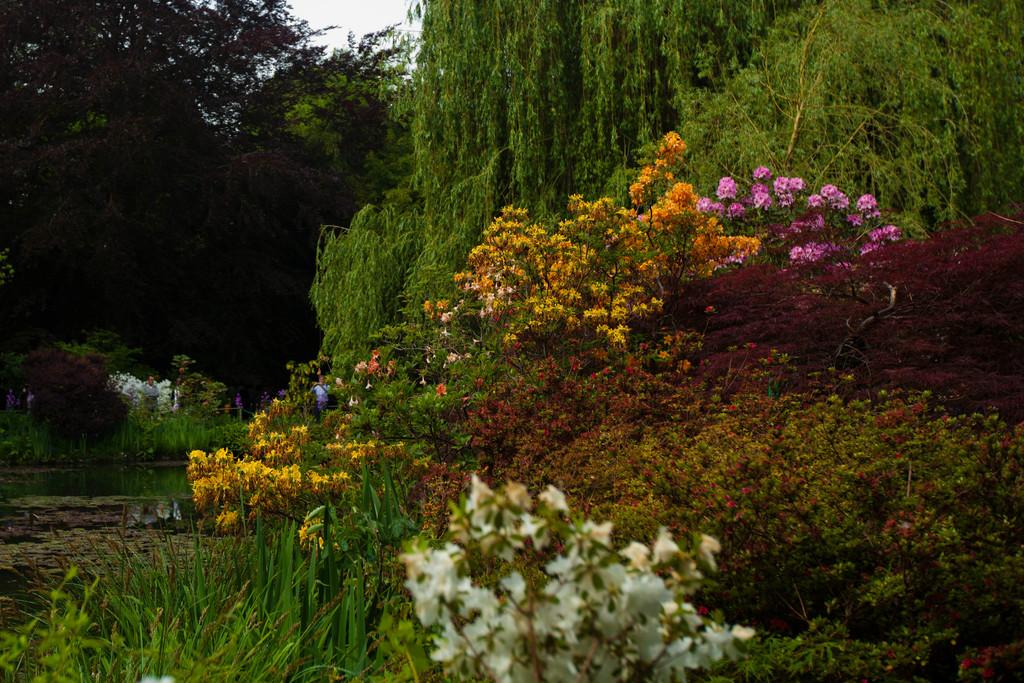What type of vegetation can be seen in the image? There is grass and trees visible in the image. Are there any plants with flowers in the image? Yes, there are flowers on a plant in the image. What can be seen in the background of the image? The sky is visible in the background of the image. What is the condition of the water in the image? The water is visible in the image, but its condition cannot be determined from the provided facts. How many people are present in the image? There are people standing in the image, but the exact number cannot be determined from the provided facts. What is the purpose of the fence in the image? The purpose of the fence in the image cannot be determined from the provided facts. What type of cough can be heard from the pigs in the image? There are no pigs present in the image, and therefore no cough can be heard. 